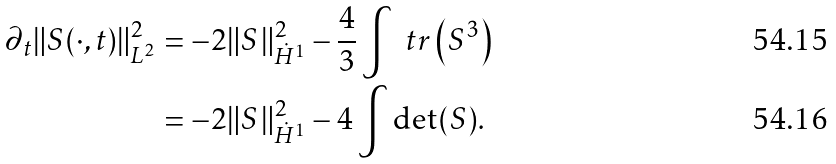Convert formula to latex. <formula><loc_0><loc_0><loc_500><loc_500>\partial _ { t } \| S ( \cdot , t ) \| _ { L ^ { 2 } } ^ { 2 } & = - 2 \| S \| _ { \dot { H } ^ { 1 } } ^ { 2 } - \frac { 4 } { 3 } \int \ t r \left ( S ^ { 3 } \right ) \\ & = - 2 \| S \| _ { \dot { H } ^ { 1 } } ^ { 2 } - 4 \int \det ( S ) .</formula> 